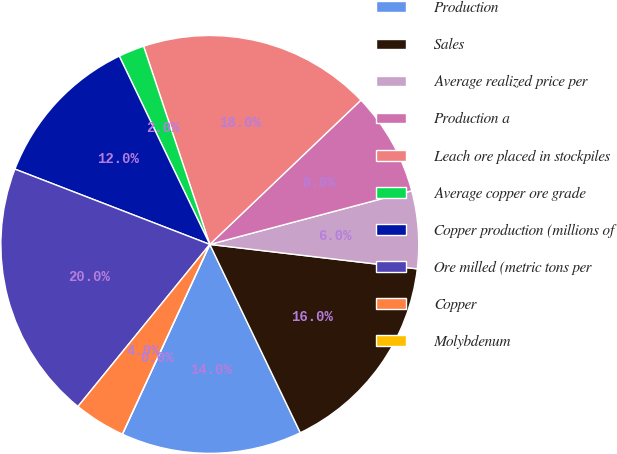<chart> <loc_0><loc_0><loc_500><loc_500><pie_chart><fcel>Production<fcel>Sales<fcel>Average realized price per<fcel>Production a<fcel>Leach ore placed in stockpiles<fcel>Average copper ore grade<fcel>Copper production (millions of<fcel>Ore milled (metric tons per<fcel>Copper<fcel>Molybdenum<nl><fcel>14.0%<fcel>16.0%<fcel>6.0%<fcel>8.0%<fcel>18.0%<fcel>2.0%<fcel>12.0%<fcel>20.0%<fcel>4.0%<fcel>0.0%<nl></chart> 